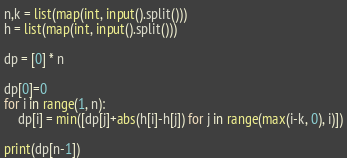<code> <loc_0><loc_0><loc_500><loc_500><_Python_>n,k = list(map(int, input().split()))
h = list(map(int, input().split()))

dp = [0] * n

dp[0]=0
for i in range(1, n):
    dp[i] = min([dp[j]+abs(h[i]-h[j]) for j in range(max(i-k, 0), i)])

print(dp[n-1])</code> 